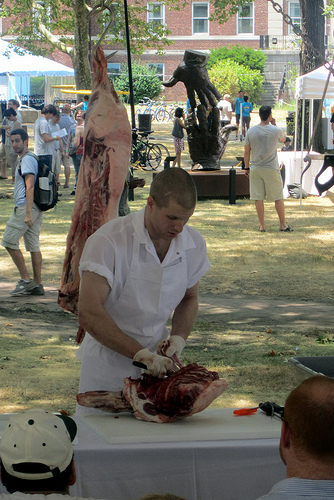<image>
Can you confirm if the ground is to the right of the man making? Yes. From this viewpoint, the ground is positioned to the right side relative to the man making. 